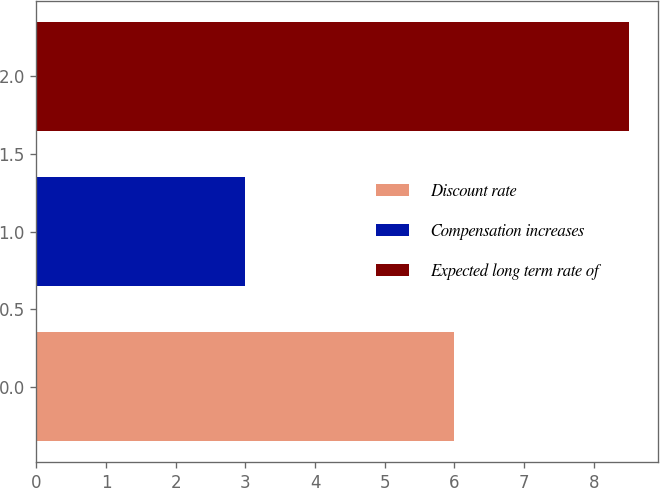Convert chart. <chart><loc_0><loc_0><loc_500><loc_500><bar_chart><fcel>Discount rate<fcel>Compensation increases<fcel>Expected long term rate of<nl><fcel>6<fcel>3<fcel>8.5<nl></chart> 